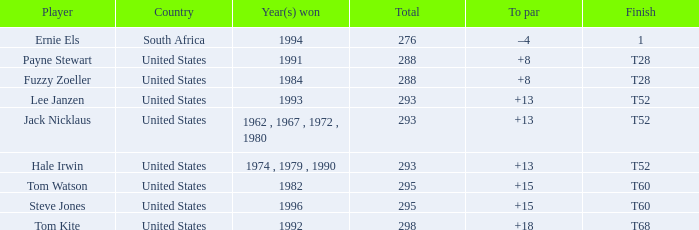What year did player steve jones, who had a t60 finish, win? 1996.0. 